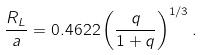Convert formula to latex. <formula><loc_0><loc_0><loc_500><loc_500>\frac { R _ { L } } { a } = 0 . 4 6 2 2 \left ( \frac { q } { 1 + q } \right ) ^ { 1 / 3 } .</formula> 